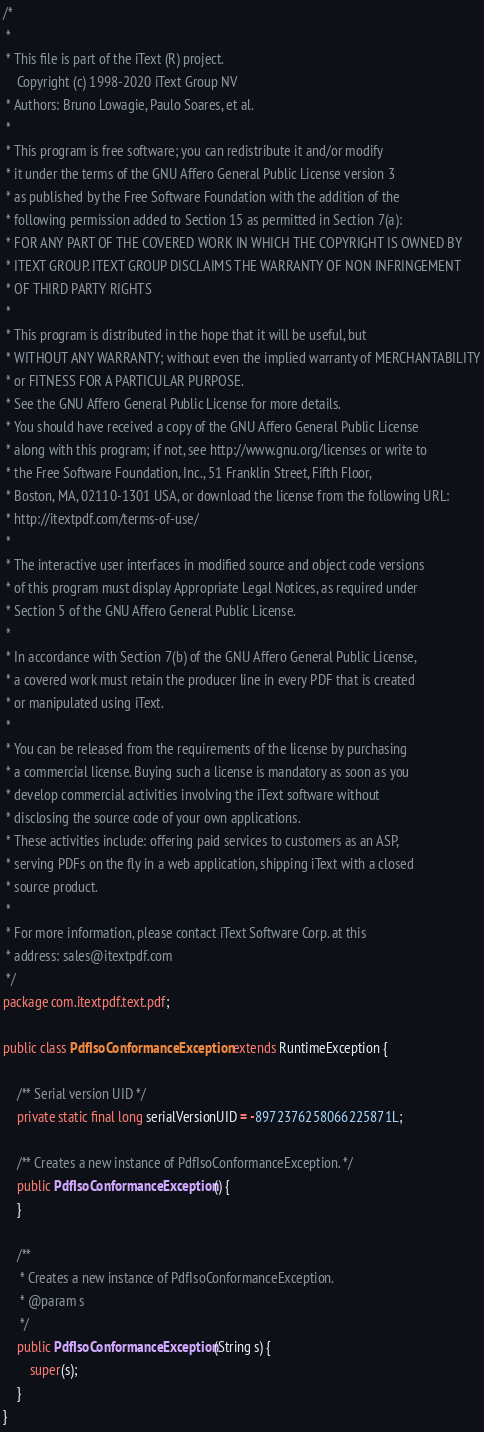<code> <loc_0><loc_0><loc_500><loc_500><_Java_>/*
 *
 * This file is part of the iText (R) project.
    Copyright (c) 1998-2020 iText Group NV
 * Authors: Bruno Lowagie, Paulo Soares, et al.
 *
 * This program is free software; you can redistribute it and/or modify
 * it under the terms of the GNU Affero General Public License version 3
 * as published by the Free Software Foundation with the addition of the
 * following permission added to Section 15 as permitted in Section 7(a):
 * FOR ANY PART OF THE COVERED WORK IN WHICH THE COPYRIGHT IS OWNED BY
 * ITEXT GROUP. ITEXT GROUP DISCLAIMS THE WARRANTY OF NON INFRINGEMENT
 * OF THIRD PARTY RIGHTS
 *
 * This program is distributed in the hope that it will be useful, but
 * WITHOUT ANY WARRANTY; without even the implied warranty of MERCHANTABILITY
 * or FITNESS FOR A PARTICULAR PURPOSE.
 * See the GNU Affero General Public License for more details.
 * You should have received a copy of the GNU Affero General Public License
 * along with this program; if not, see http://www.gnu.org/licenses or write to
 * the Free Software Foundation, Inc., 51 Franklin Street, Fifth Floor,
 * Boston, MA, 02110-1301 USA, or download the license from the following URL:
 * http://itextpdf.com/terms-of-use/
 *
 * The interactive user interfaces in modified source and object code versions
 * of this program must display Appropriate Legal Notices, as required under
 * Section 5 of the GNU Affero General Public License.
 *
 * In accordance with Section 7(b) of the GNU Affero General Public License,
 * a covered work must retain the producer line in every PDF that is created
 * or manipulated using iText.
 *
 * You can be released from the requirements of the license by purchasing
 * a commercial license. Buying such a license is mandatory as soon as you
 * develop commercial activities involving the iText software without
 * disclosing the source code of your own applications.
 * These activities include: offering paid services to customers as an ASP,
 * serving PDFs on the fly in a web application, shipping iText with a closed
 * source product.
 *
 * For more information, please contact iText Software Corp. at this
 * address: sales@itextpdf.com
 */
package com.itextpdf.text.pdf;

public class PdfIsoConformanceException extends RuntimeException {

	/** Serial version UID */
	private static final long serialVersionUID = -8972376258066225871L;

	/** Creates a new instance of PdfIsoConformanceException. */
    public PdfIsoConformanceException() {
    }

    /**
     * Creates a new instance of PdfIsoConformanceException.
     * @param s
     */
    public PdfIsoConformanceException(String s) {
        super(s);
    }    
}
</code> 